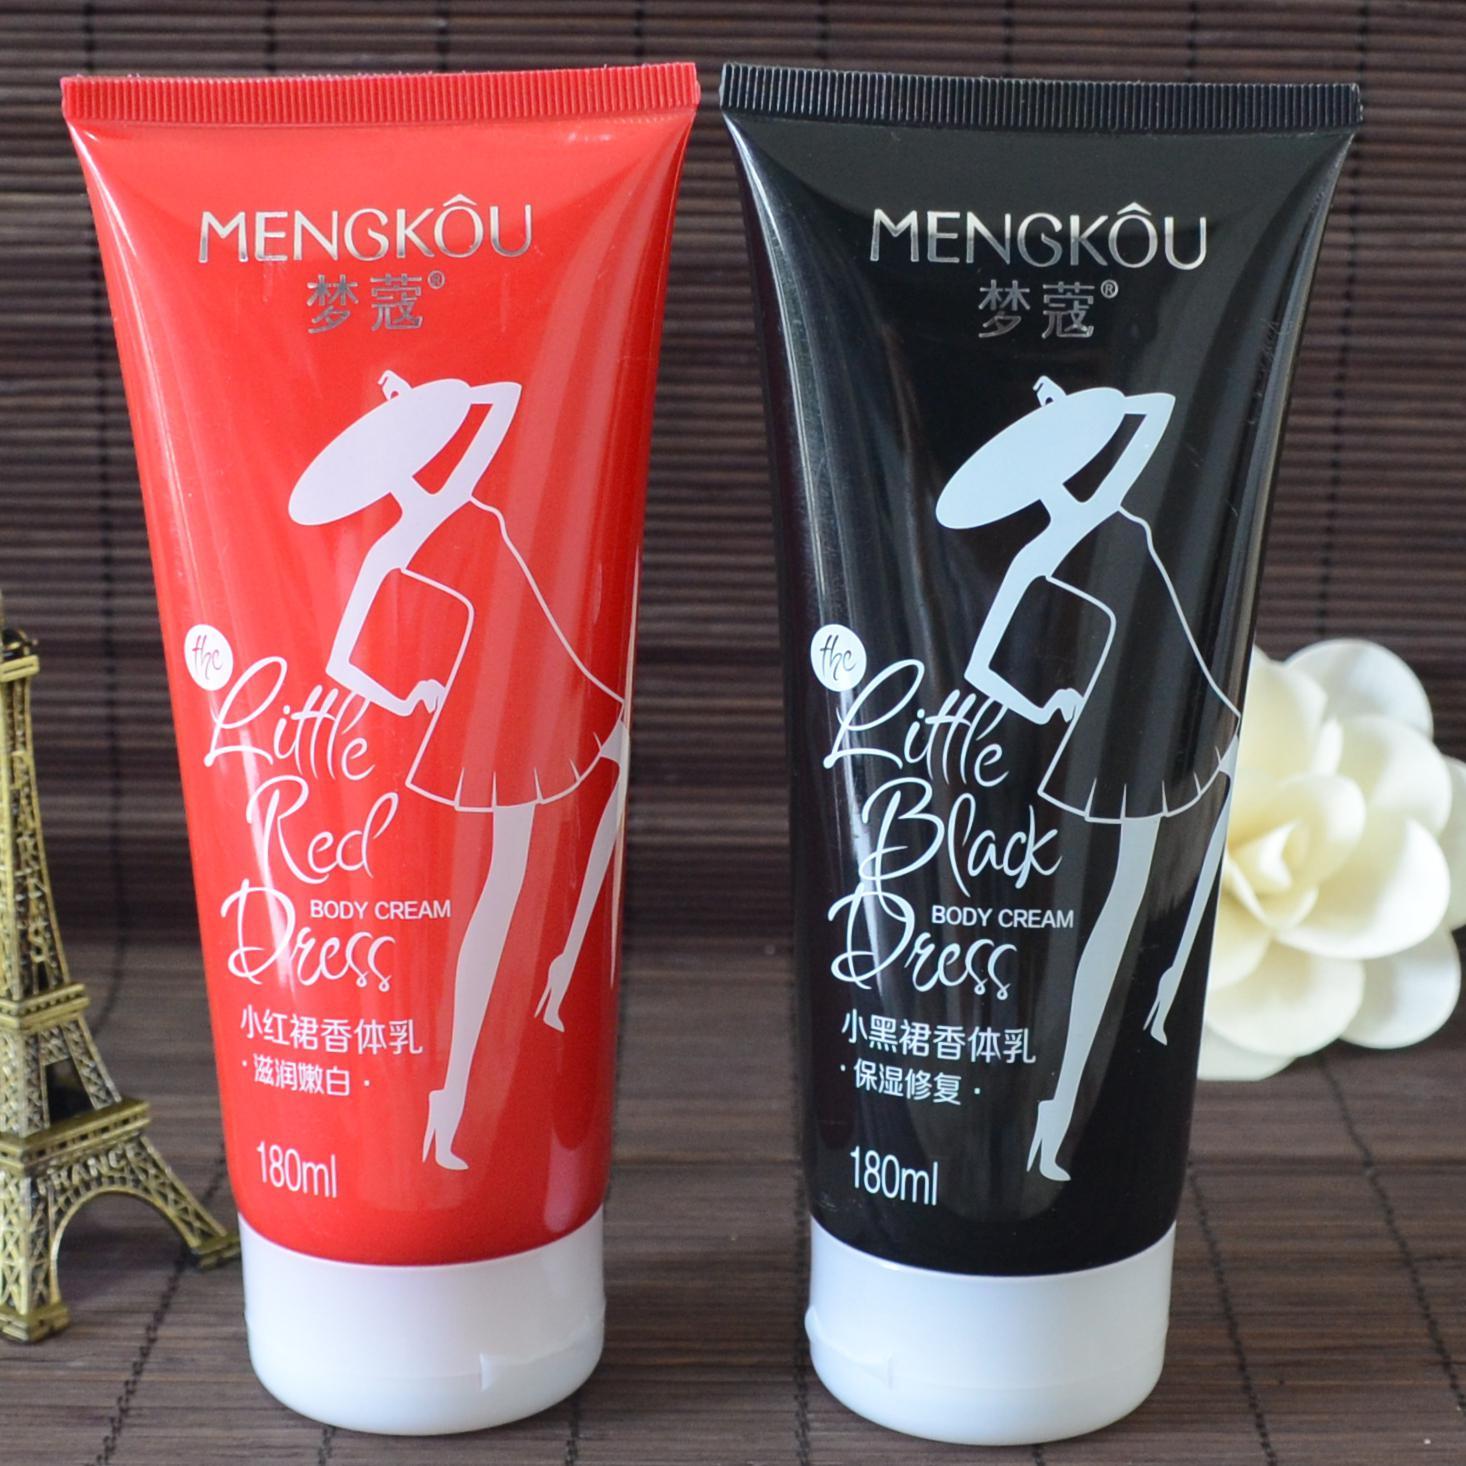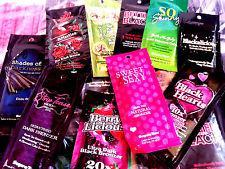The first image is the image on the left, the second image is the image on the right. Assess this claim about the two images: "There are only two bottles in one of the images.". Correct or not? Answer yes or no. Yes. 